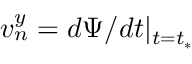<formula> <loc_0><loc_0><loc_500><loc_500>v _ { n } ^ { y } = d \Psi / d t | _ { t = t _ { * } }</formula> 